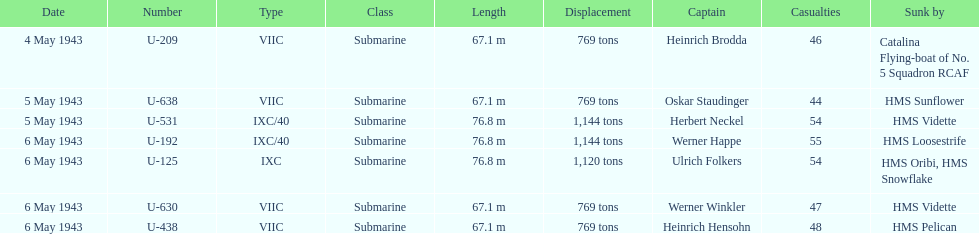What is the only vessel to sink multiple u-boats? HMS Vidette. I'm looking to parse the entire table for insights. Could you assist me with that? {'header': ['Date', 'Number', 'Type', 'Class', 'Length', 'Displacement', 'Captain', 'Casualties', 'Sunk by'], 'rows': [['4 May 1943', 'U-209', 'VIIC', 'Submarine', '67.1 m', '769 tons', 'Heinrich Brodda', '46', 'Catalina Flying-boat of No. 5 Squadron RCAF'], ['5 May 1943', 'U-638', 'VIIC', 'Submarine', '67.1 m', '769 tons', 'Oskar Staudinger', '44', 'HMS Sunflower'], ['5 May 1943', 'U-531', 'IXC/40', 'Submarine', '76.8 m', '1,144 tons', 'Herbert Neckel', '54', 'HMS Vidette'], ['6 May 1943', 'U-192', 'IXC/40', 'Submarine', '76.8 m', '1,144 tons', 'Werner Happe', '55', 'HMS Loosestrife'], ['6 May 1943', 'U-125', 'IXC', 'Submarine', '76.8 m', '1,120 tons', 'Ulrich Folkers', '54', 'HMS Oribi, HMS Snowflake'], ['6 May 1943', 'U-630', 'VIIC', 'Submarine', '67.1 m', '769 tons', 'Werner Winkler', '47', 'HMS Vidette'], ['6 May 1943', 'U-438', 'VIIC', 'Submarine', '67.1 m', '769 tons', 'Heinrich Hensohn', '48', 'HMS Pelican']]} 